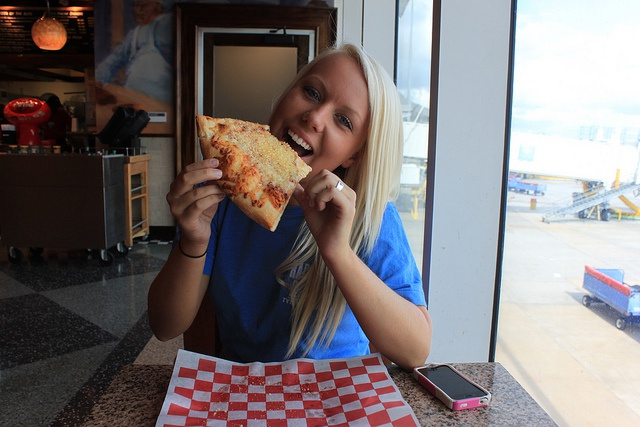Describe the objects in this image and their specific colors. I can see people in black, maroon, and gray tones, dining table in black, darkgray, maroon, and brown tones, pizza in black, tan, brown, and maroon tones, cell phone in black, gray, darkblue, and darkgray tones, and people in black and maroon tones in this image. 